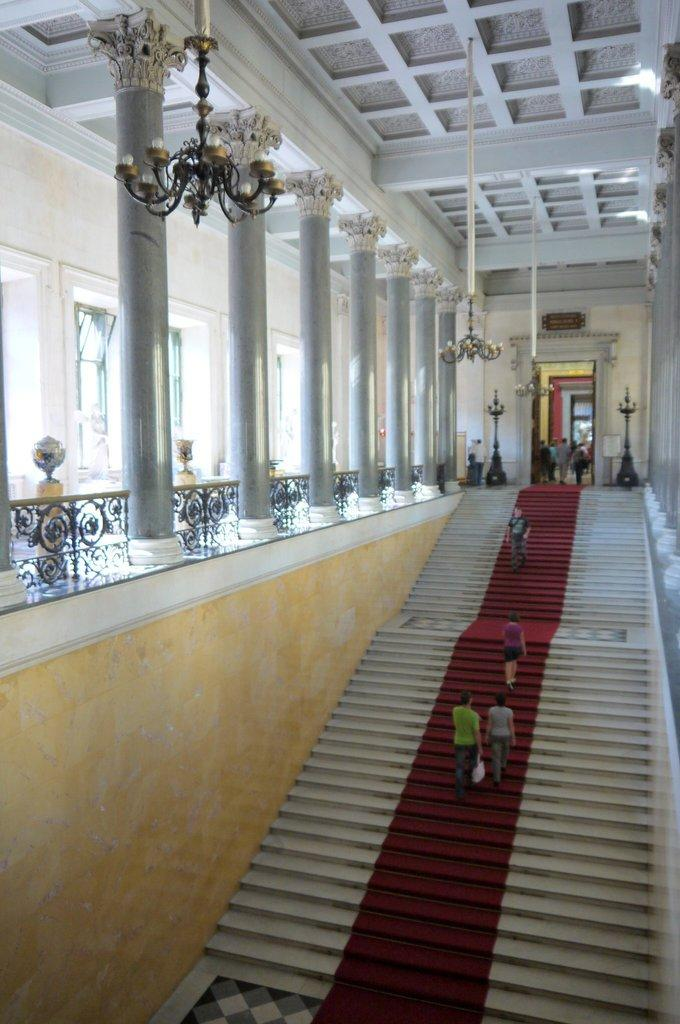What type of structure is present in the image? There are stairs in the image. Are there any people in the image? Yes, there are people on the stairs. What other architectural features can be seen in the image? There are pillars in the image. What type of barrier is visible in the image? There is a fence in the image. Can you see any sheep grazing near the stream in the image? There is no stream or sheep present in the image. 